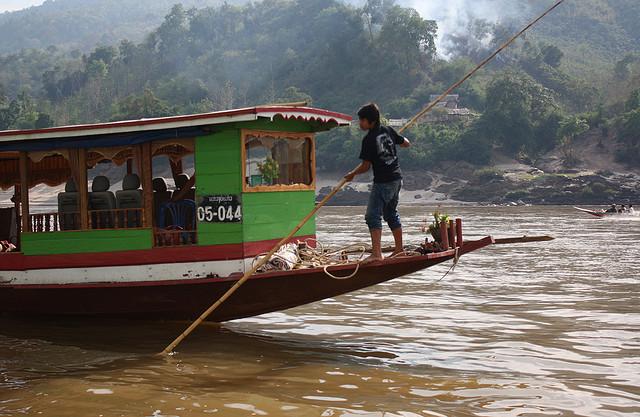Is the person steering young or old?
Write a very short answer. Young. Does this look like a public or private boat?
Answer briefly. Public. Is this man holding a tennis racket?
Keep it brief. No. 